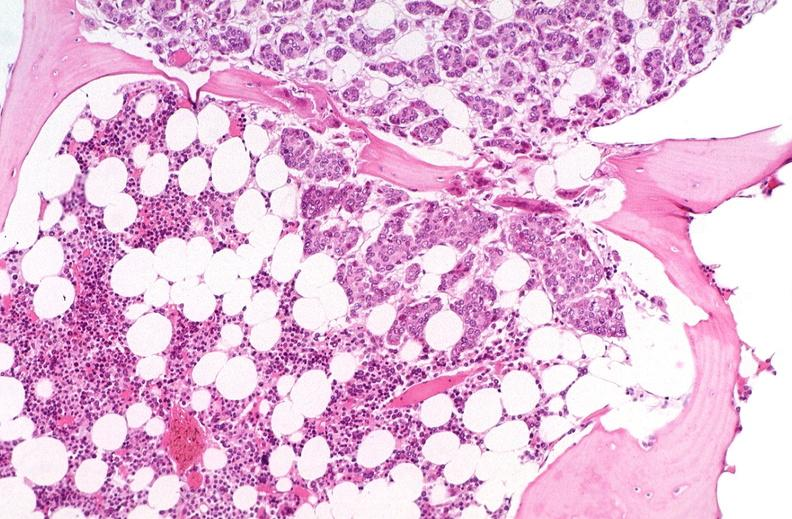does omphalocele show breast cancer metastasis to bone marrow?
Answer the question using a single word or phrase. No 